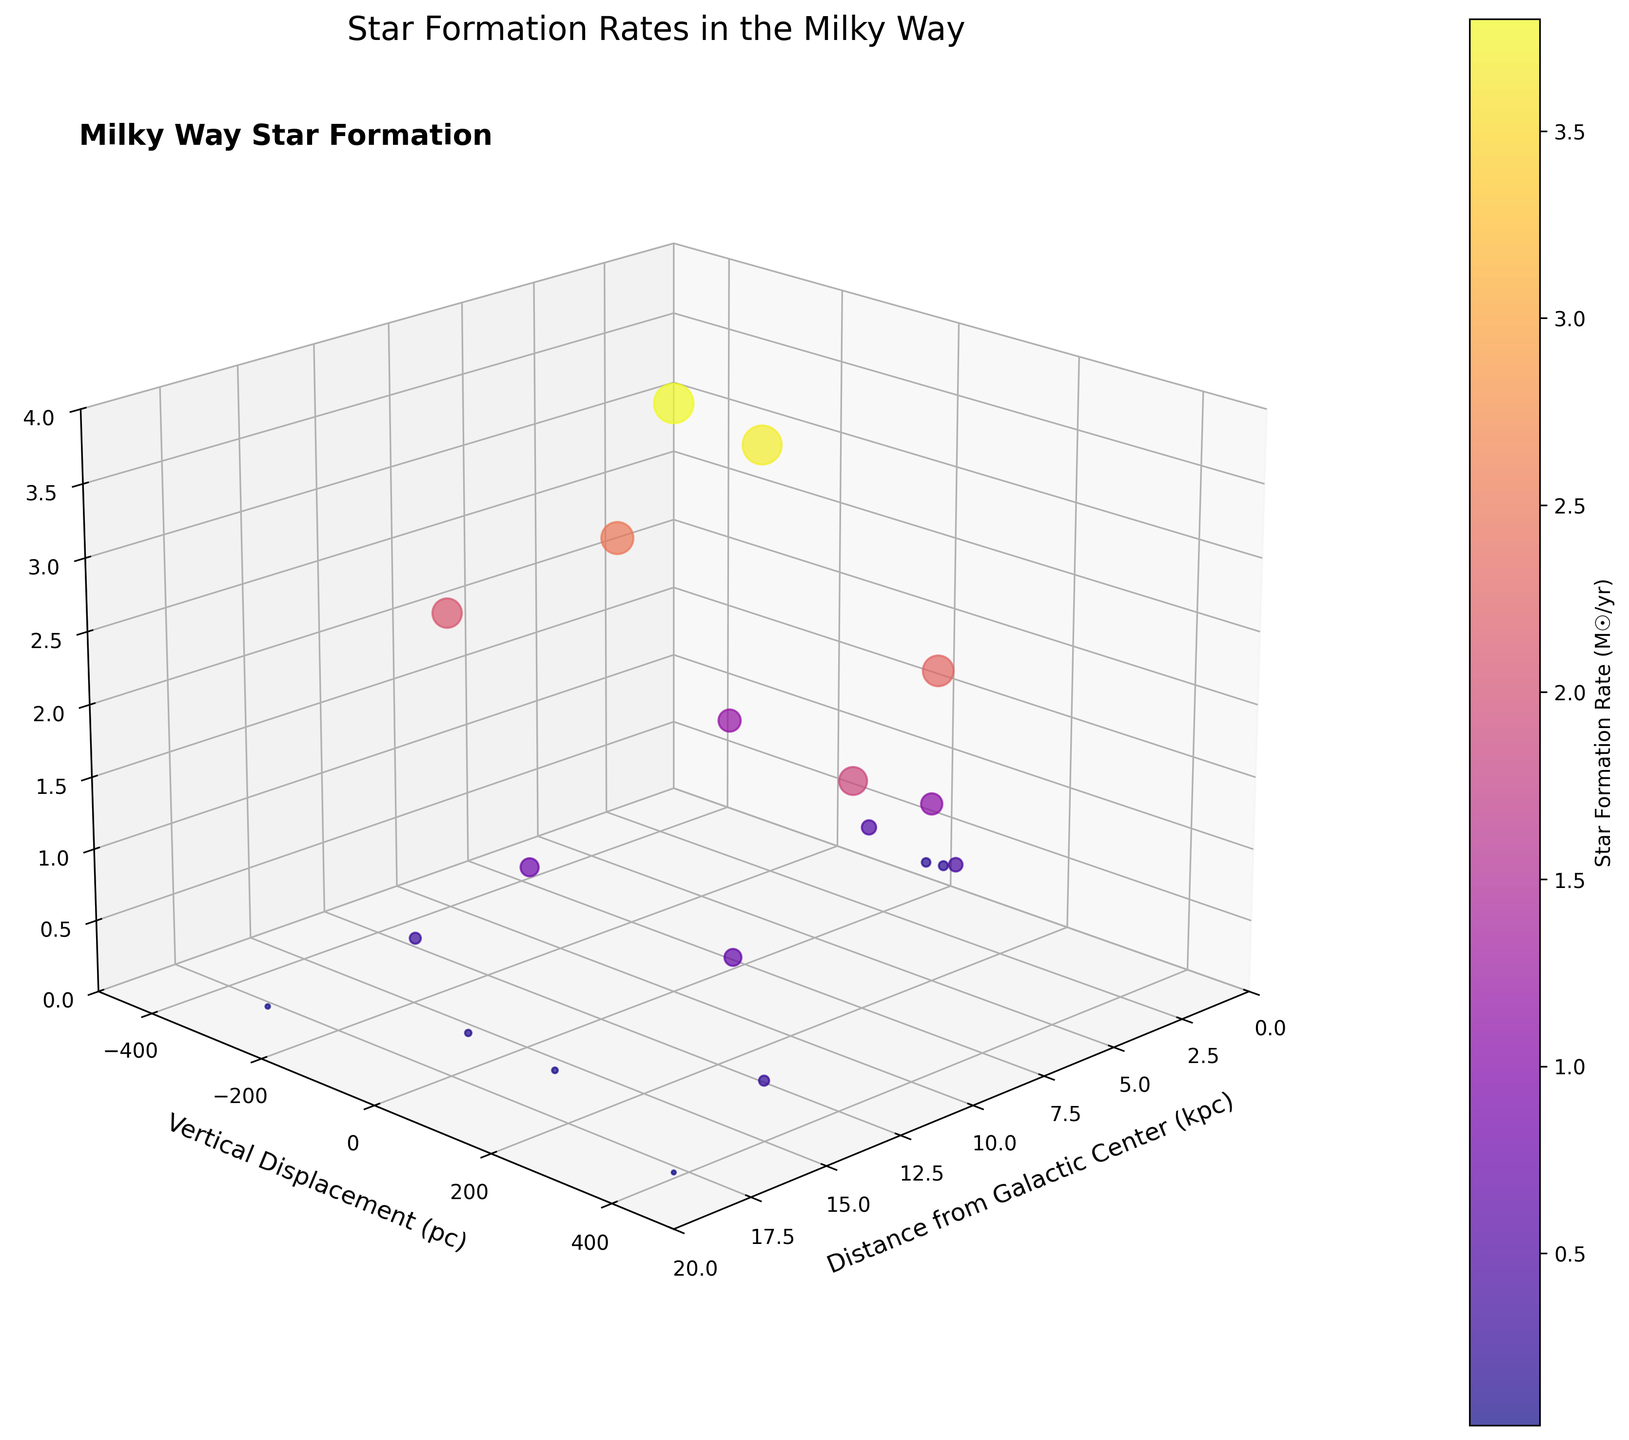what's the title of the figure? The title is located at the top of the figure, often summarizing what the plot represents. In this case, it states "Star Formation Rates in the Milky Way".
Answer: Star Formation Rates in the Milky Way How many data points are shown in the figure? You can determine the number of data points by counting the individual scatter markers in the plot. Each point represents a data entry from the provided dataset.
Answer: 20 Which data point has the highest star formation rate? By identifying the point at the highest position on the z-axis (Star Formation Rate), it appears to be the one at (8 kpc, -100 pc). This point’s vertical position in the plot is the highest, indicating the peak star formation rate.
Answer: (8 kpc, -100 pc) At what vertical displacement does the star formation rate drop below 0.5 solar masses per year farthest from the galactic center? By examining the data points with SFR < 0.5 M☉/yr and finding the largest Vertical Displacement, the point at (18 kpc, 400 pc) fulfills these criteria.
Answer: 400 pc What is the average star formation rate for data points at 4 kpc and 6 kpc from the galactic center? For points at 4 kpc: (1.2, 1.1); Total = 2.3, Average = 2.3/2 = 1.15; for points at 6 kpc: (2.5, 2.3); Total = 4.8, Average = 4.8/2 = 2.4
Answer: 1.15 at 4 kpc, 2.4 at 6 kpc Which vertical displacement shows the highest concentration of high star formation rates (above 2 solar masses per year)? Identifying the data points with SFR > 2 M☉/yr and checking their Vertical Displacement shows -100 pc and 50 pc near 8 kpc region with high SFR values of 3.8 and 3.7 M☉/yr respectively.
Answer: -100 pc and 50 pc Between 10 kpc and 14 kpc from the galactic center, which has higher star formation rates on average? For 10 kpc: (2.1, 1.9); Average = (2.1 + 1.9)/2 = 2; For 14 kpc: (0.3, 0.25); Average = (0.3 + 0.25)/2 = 0.275; So, 10 kpc has a higher average SFR.
Answer: 10 kpc What is the star formation rate at the galactic center (0.5 kpc) and how does it compare to that at 8 kpc? At 0.5 kpc, SFR values are 0.2 and 0.18; At 8 kpc, SFR values are 3.8 and 3.7; Comparison shows that 8 kpc has significantly higher SFRs.
Answer: Much higher at 8 kpc What trend can you observe as you move further from the galactic center in terms of star formation rate? As observed, SFR generally increases until around 8 kpc and then starts to decrease beyond this distance. High SFR values cluster around 4-10 kpc.
Answer: Increases then decreases Expain the correlation (if any) between vertical displacement from the galactic plane and star formation rates. Generally, points closer to the galactic plane (smaller displacements) tend to have higher star formation rates, with SFR dropping off further away.
Answer: Higher SFR near the galactic plane 